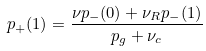Convert formula to latex. <formula><loc_0><loc_0><loc_500><loc_500>p _ { + } ( 1 ) = \frac { \nu p _ { - } ( 0 ) + \nu _ { R } p _ { - } ( 1 ) } { p _ { g } + \nu _ { c } }</formula> 